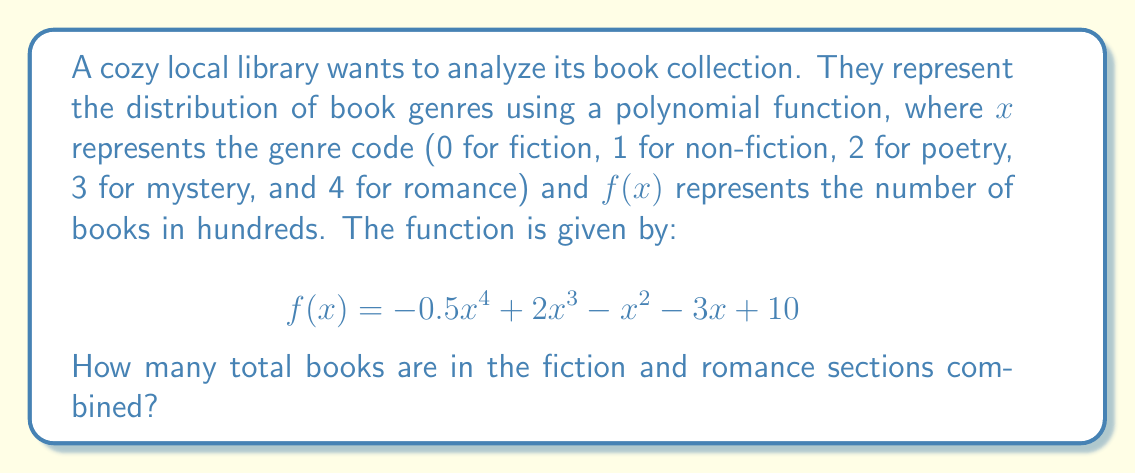Give your solution to this math problem. Let's approach this step-by-step:

1) We need to find the number of books in the fiction and romance sections.

2) Fiction is represented by $x = 0$, and romance by $x = 4$.

3) For fiction (x = 0):
   $$f(0) = -0.5(0)^4 + 2(0)^3 - (0)^2 - 3(0) + 10 = 10$$
   This means there are 1000 fiction books (remember, the function gives results in hundreds).

4) For romance (x = 4):
   $$f(4) = -0.5(4)^4 + 2(4)^3 - (4)^2 - 3(4) + 10$$
   $$= -0.5(256) + 2(64) - 16 - 12 + 10$$
   $$= -128 + 128 - 16 - 12 + 10$$
   $$= -18$$
   This means there are no romance books, as a negative number of books doesn't make sense in reality. We'll consider this as 0 books.

5) Total books = Fiction books + Romance books
                = 1000 + 0 = 1000

Therefore, there are 1000 books in the fiction and romance sections combined.
Answer: 1000 books 